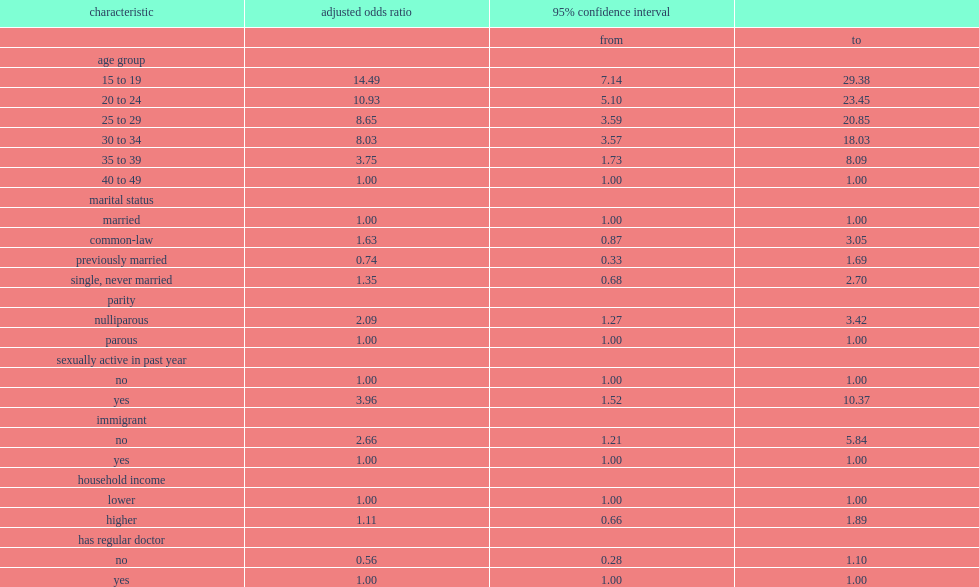Was the adjusted odds of oc use higher for women aged 15 to 19 or was that for those aged 40 to 49? 15 to 19. Was the adjusted odds of oc use higher for women aged 20 to 24 or was that for those aged 40 to 49? 20 to 24. Was the adjusted odds of oc use higher for women aged 25 to 29 or was that for those aged 40 to 49? 25 to 29. Was the adjusted odds of oc use higher for women aged 30 to 34 or was that for those aged 40 to 49? 30 to 34. Was the adjusted odds of oc use higher for women aged 35 to 39 or was that for those aged 40 to 49? 35 to 39. Were the adjusted odds higher in women who were nulliparous or were that in parous ones? Nulliparous. Were the adjusted odds higher in women who were sexually active in the past year or were that in inactive ones? Sexually active in past year yes. Were the adjusted odds higher in women who were canadian-born or were that in immigrant ones? Immigrant no. 